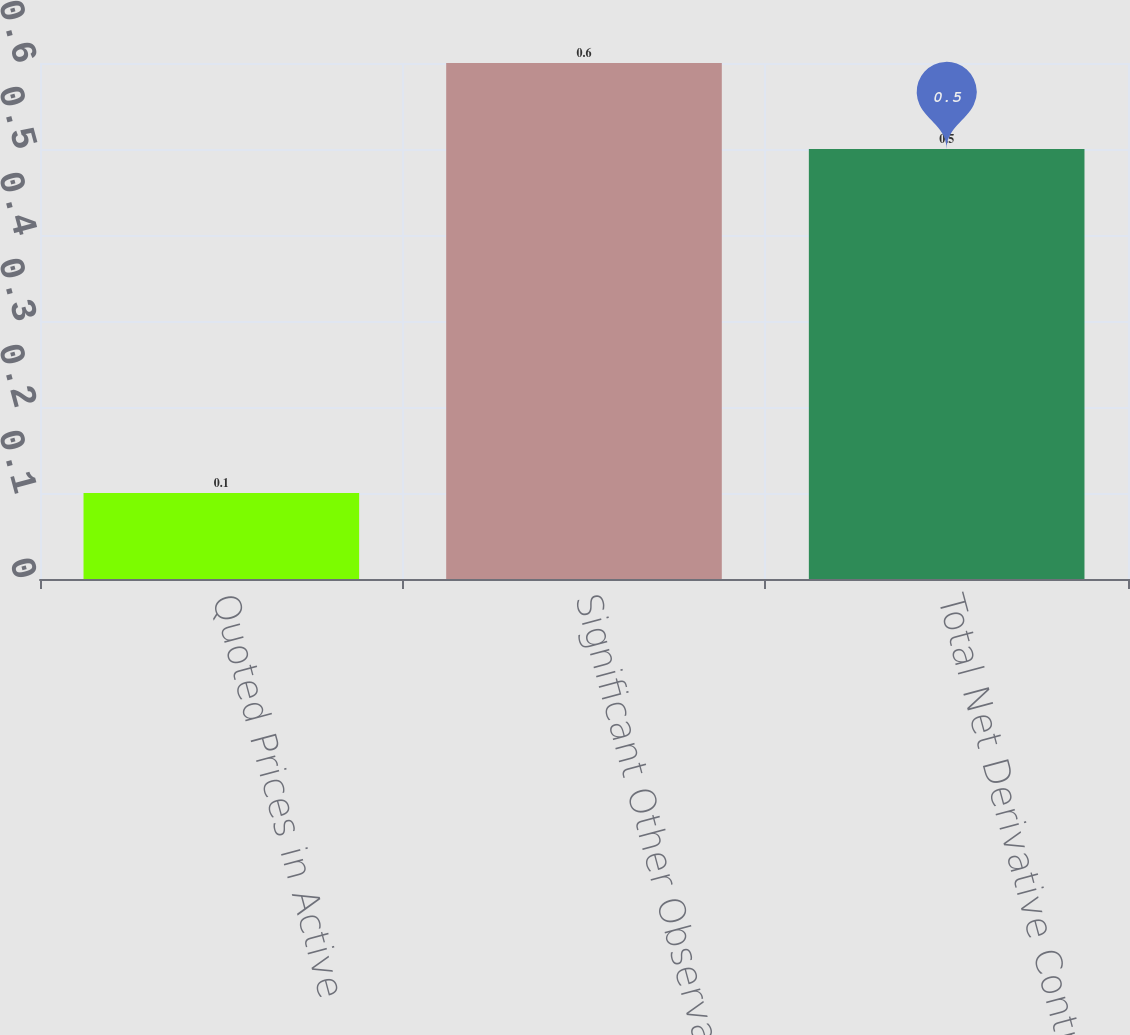Convert chart to OTSL. <chart><loc_0><loc_0><loc_500><loc_500><bar_chart><fcel>Quoted Prices in Active<fcel>Significant Other Observable<fcel>Total Net Derivative Contracts<nl><fcel>0.1<fcel>0.6<fcel>0.5<nl></chart> 